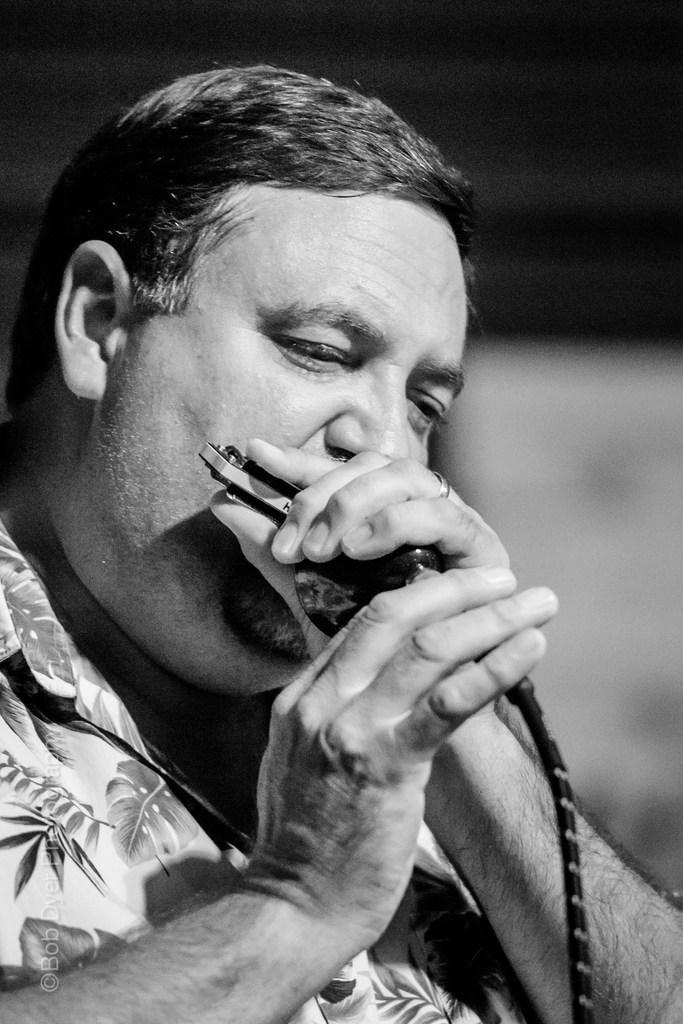How would you summarize this image in a sentence or two? Here this is a black and white image, in which we can see a person playing a musical instrument with his mouth. 